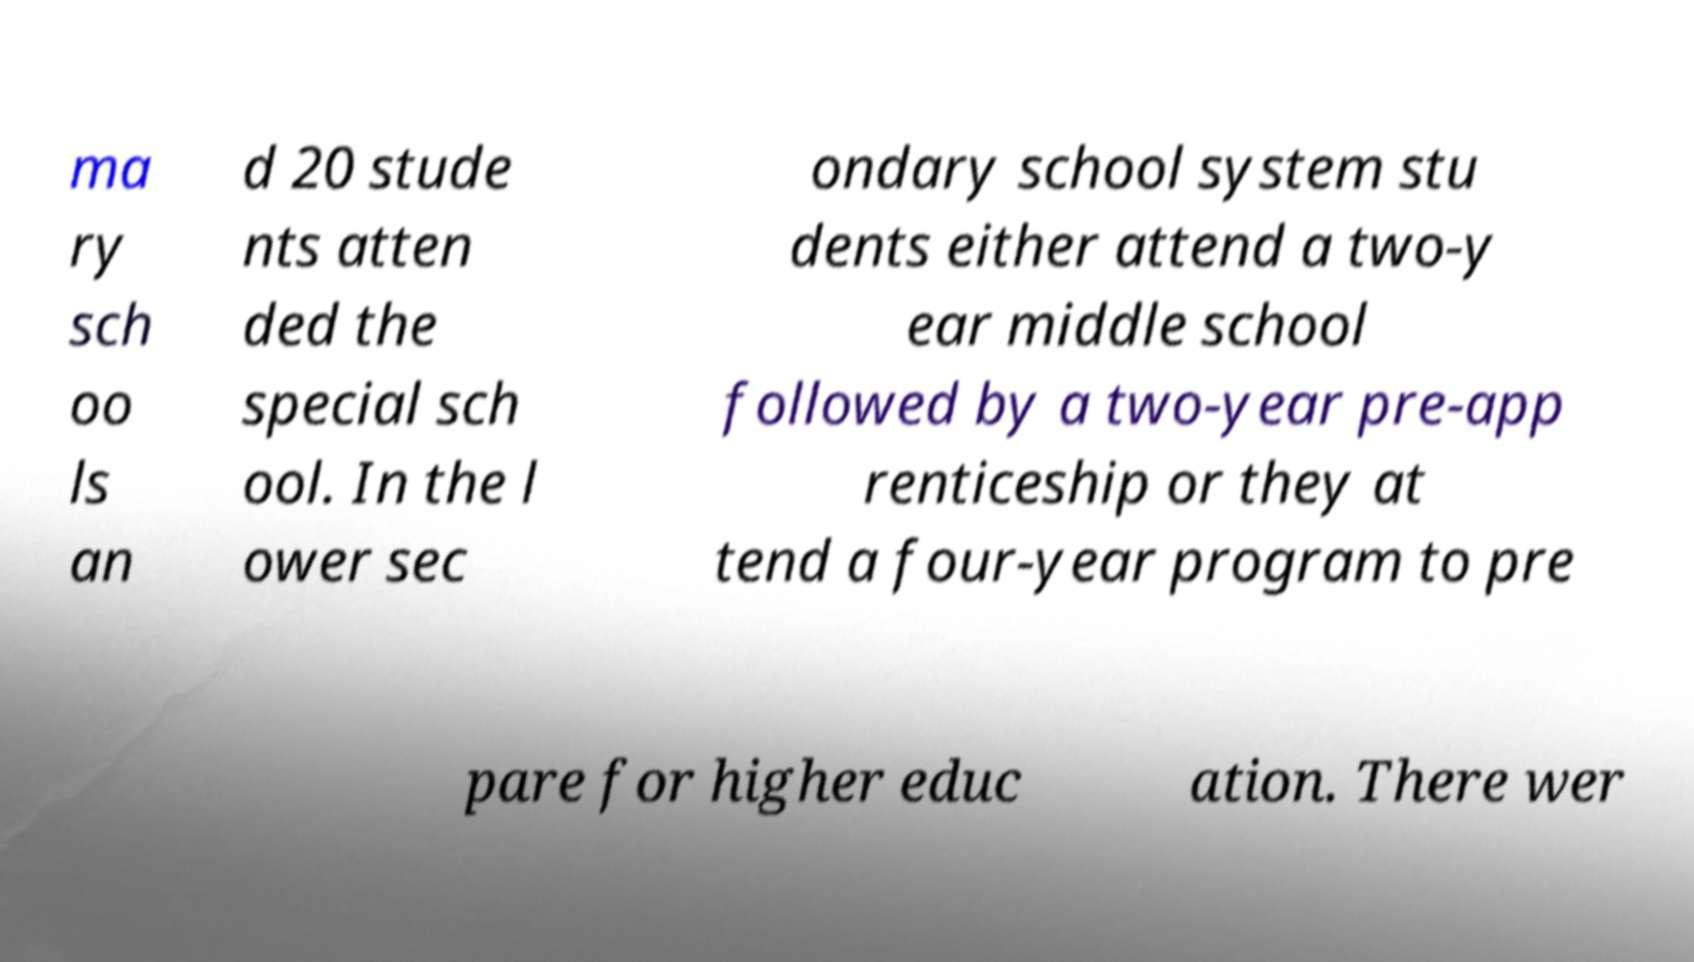Could you assist in decoding the text presented in this image and type it out clearly? ma ry sch oo ls an d 20 stude nts atten ded the special sch ool. In the l ower sec ondary school system stu dents either attend a two-y ear middle school followed by a two-year pre-app renticeship or they at tend a four-year program to pre pare for higher educ ation. There wer 